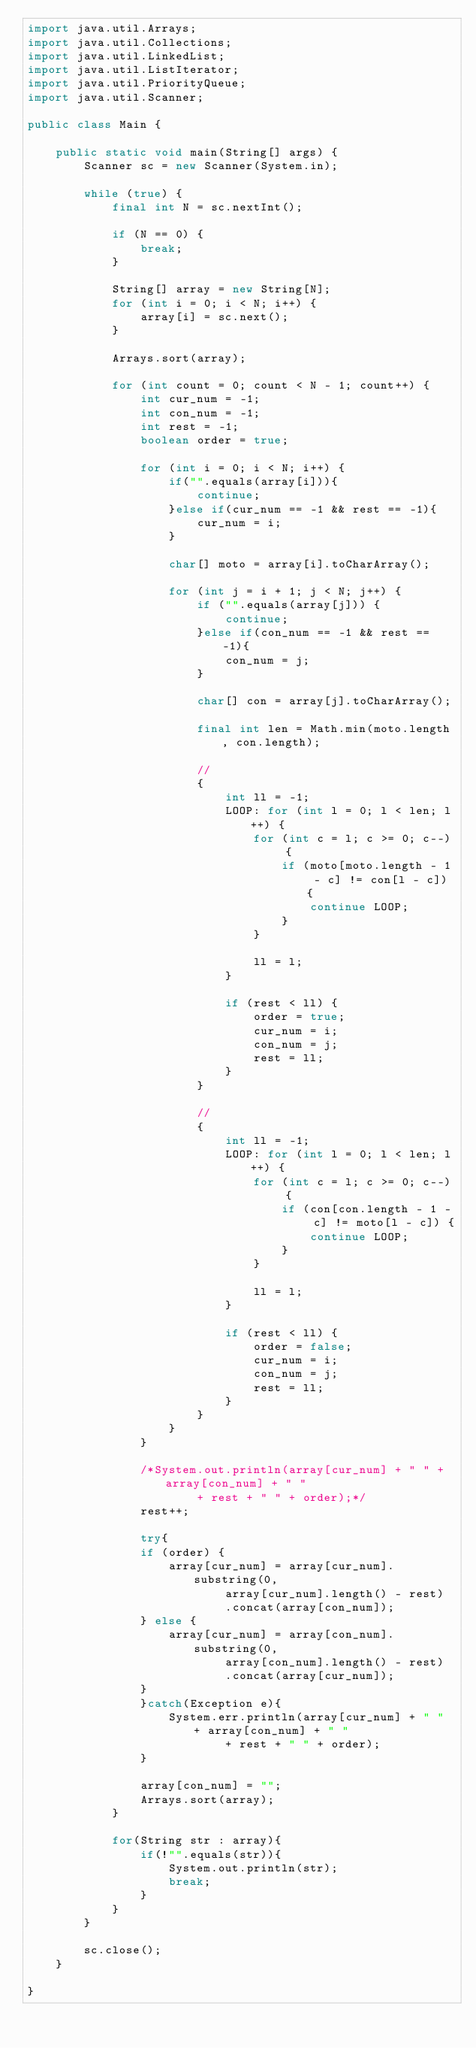Convert code to text. <code><loc_0><loc_0><loc_500><loc_500><_Java_>import java.util.Arrays;
import java.util.Collections;
import java.util.LinkedList;
import java.util.ListIterator;
import java.util.PriorityQueue;
import java.util.Scanner;

public class Main {

	public static void main(String[] args) {
		Scanner sc = new Scanner(System.in);

		while (true) {
			final int N = sc.nextInt();

			if (N == 0) {
				break;
			}

			String[] array = new String[N];
			for (int i = 0; i < N; i++) {
				array[i] = sc.next();
			}

			Arrays.sort(array);

			for (int count = 0; count < N - 1; count++) {
				int cur_num = -1;
				int con_num = -1;
				int rest = -1;
				boolean order = true;
				
				for (int i = 0; i < N; i++) {
					if("".equals(array[i])){
						continue;
					}else if(cur_num == -1 && rest == -1){
						cur_num = i;
					}
					
					char[] moto = array[i].toCharArray();

					for (int j = i + 1; j < N; j++) {
						if ("".equals(array[j])) {
							continue;
						}else if(con_num == -1 && rest == -1){
							con_num = j;
						}

						char[] con = array[j].toCharArray();

						final int len = Math.min(moto.length, con.length);

						//
						{
							int ll = -1;
							LOOP: for (int l = 0; l < len; l++) {
								for (int c = l; c >= 0; c--) {
									if (moto[moto.length - 1 - c] != con[l - c]) {
										continue LOOP;
									}
								}

								ll = l;
							}

							if (rest < ll) {
								order = true;
								cur_num = i;
								con_num = j;
								rest = ll;
							}
						}

						//
						{
							int ll = -1;
							LOOP: for (int l = 0; l < len; l++) {
								for (int c = l; c >= 0; c--) {
									if (con[con.length - 1 - c] != moto[l - c]) {
										continue LOOP;
									}
								}

								ll = l;
							}

							if (rest < ll) {
								order = false;
								cur_num = i;
								con_num = j;
								rest = ll;
							}
						}
					}
				}
				
				/*System.out.println(array[cur_num] + " " + array[con_num] + " "
						+ rest + " " + order);*/
				rest++;
				
				try{
				if (order) {
					array[cur_num] = array[cur_num].substring(0,
							array[cur_num].length() - rest)
							.concat(array[con_num]);
				} else {
					array[cur_num] = array[con_num].substring(0,
							array[con_num].length() - rest)
							.concat(array[cur_num]);
				}
				}catch(Exception e){
					System.err.println(array[cur_num] + " " + array[con_num] + " "
							+ rest + " " + order);
				}
				
				array[con_num] = "";
				Arrays.sort(array);
			}

			for(String str : array){
				if(!"".equals(str)){
					System.out.println(str);
					break;
				}
			}
		}

		sc.close();
	}

}</code> 